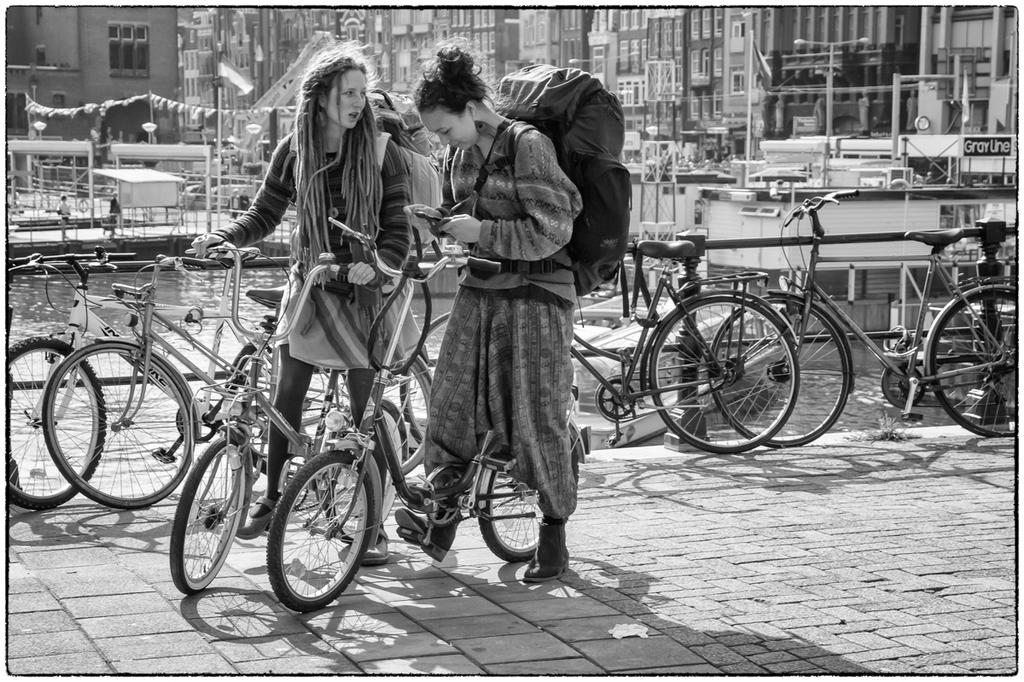How many women are in the image? There are two women in the image. What are the women carrying? The women are carrying travel bags. How are the women positioned in the image? The women are sitting on a bicycle. How many bicycles can be seen in the image? There are multiple bicycles visible in the image. What can be seen in the background of the image? There are buildings present in the background of the image. What hobbies do the women have in common, as indicated by the presence of a stem in the image? There is no stem present in the image, and therefore no indication of the women's hobbies. 